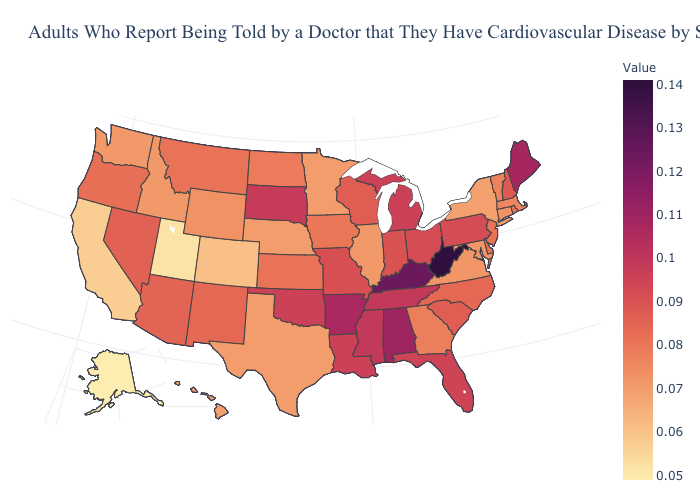Does Texas have a higher value than Kansas?
Short answer required. No. Among the states that border Mississippi , which have the lowest value?
Be succinct. Louisiana. Does Nebraska have the lowest value in the MidWest?
Be succinct. Yes. Does Alaska have the lowest value in the USA?
Short answer required. Yes. Does the map have missing data?
Keep it brief. No. Among the states that border Rhode Island , which have the lowest value?
Keep it brief. Connecticut. Which states hav the highest value in the South?
Keep it brief. West Virginia. 